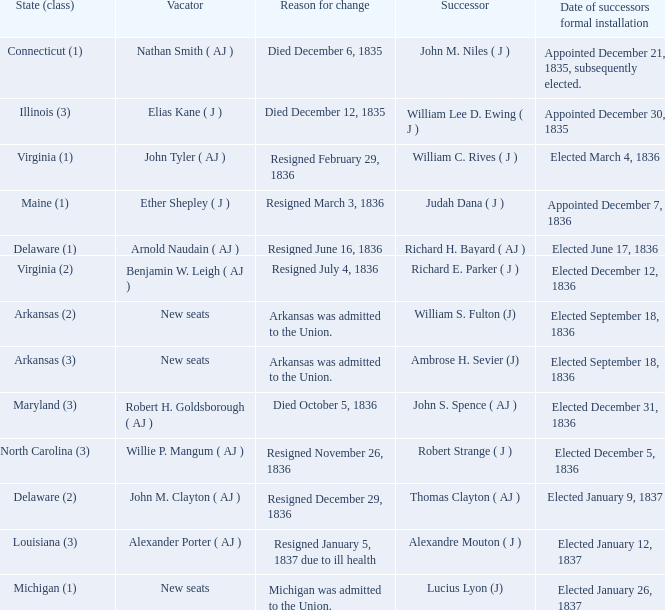Name the successor for elected january 26, 1837 1.0. 